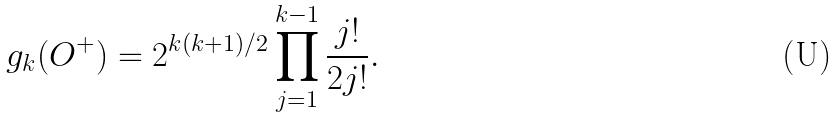<formula> <loc_0><loc_0><loc_500><loc_500>g _ { k } ( O ^ { + } ) = 2 ^ { k ( k + 1 ) / 2 } \prod _ { j = 1 } ^ { k - 1 } \frac { j ! } { 2 j ! } .</formula> 